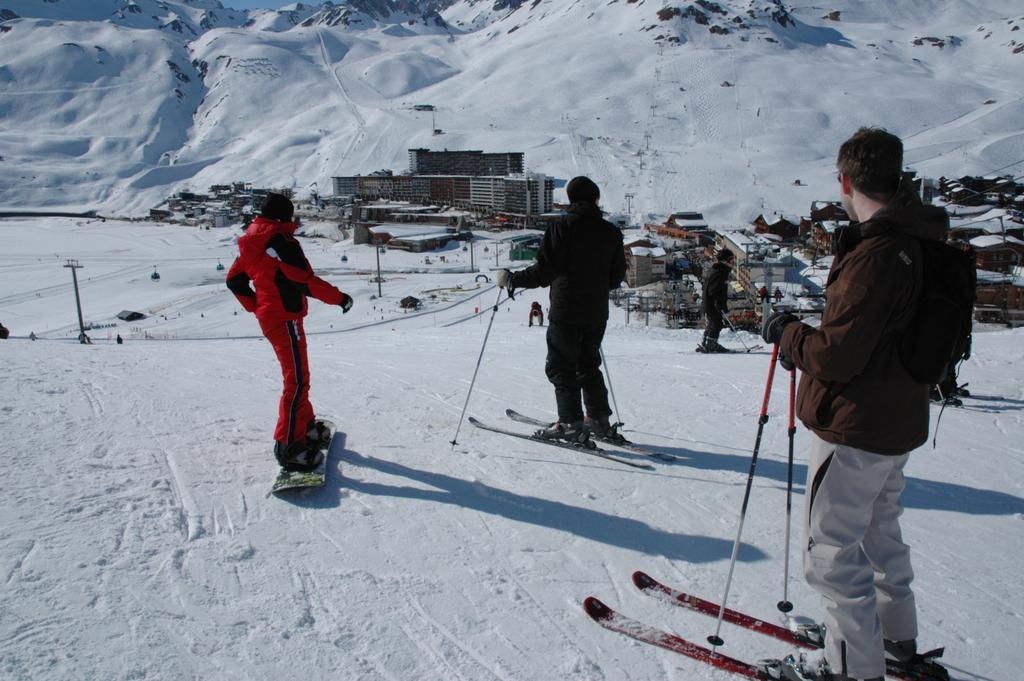In one or two sentences, can you explain what this image depicts? In this picture we can see some people holding sticks with their hands and standing on skis and in the background we can see poles, buildings, snow, mountains. 